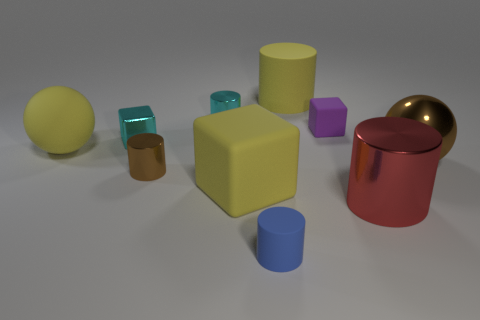Subtract all big yellow cylinders. How many cylinders are left? 4 Subtract all purple blocks. How many blocks are left? 2 Subtract 5 cylinders. How many cylinders are left? 0 Subtract all purple balls. Subtract all blue cubes. How many balls are left? 2 Subtract 0 red spheres. How many objects are left? 10 Subtract all cubes. How many objects are left? 7 Subtract all cyan cylinders. How many cyan cubes are left? 1 Subtract all large brown metallic spheres. Subtract all small brown metallic objects. How many objects are left? 8 Add 2 yellow blocks. How many yellow blocks are left? 3 Add 7 yellow rubber cylinders. How many yellow rubber cylinders exist? 8 